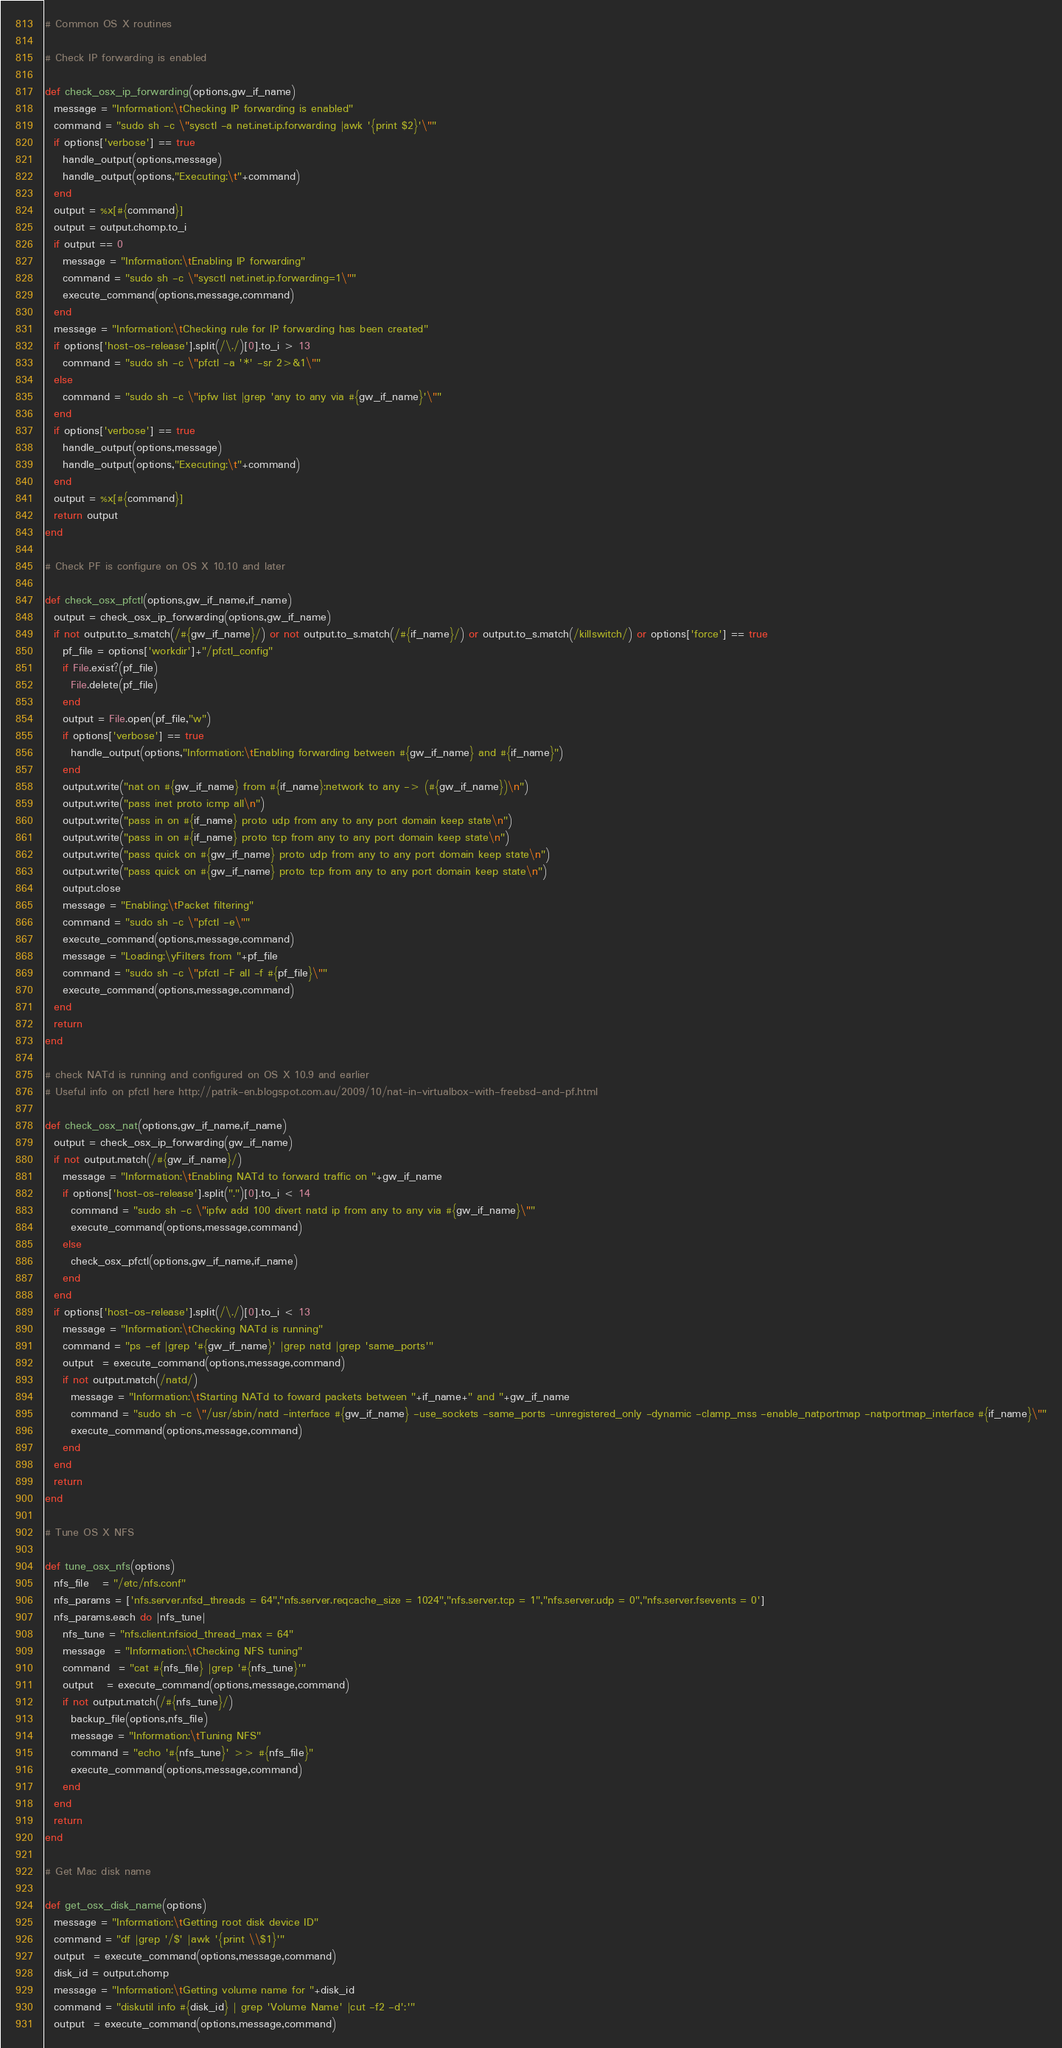<code> <loc_0><loc_0><loc_500><loc_500><_Ruby_># Common OS X routines

# Check IP forwarding is enabled

def check_osx_ip_forwarding(options,gw_if_name)
  message = "Information:\tChecking IP forwarding is enabled"
  command = "sudo sh -c \"sysctl -a net.inet.ip.forwarding |awk '{print $2}'\""
  if options['verbose'] == true
    handle_output(options,message)
    handle_output(options,"Executing:\t"+command)
  end
  output = %x[#{command}]
  output = output.chomp.to_i
  if output == 0
    message = "Information:\tEnabling IP forwarding"
    command = "sudo sh -c \"sysctl net.inet.ip.forwarding=1\""
    execute_command(options,message,command)
  end
  message = "Information:\tChecking rule for IP forwarding has been created"
  if options['host-os-release'].split(/\./)[0].to_i > 13
    command = "sudo sh -c \"pfctl -a '*' -sr 2>&1\""
  else
    command = "sudo sh -c \"ipfw list |grep 'any to any via #{gw_if_name}'\""
  end
  if options['verbose'] == true
    handle_output(options,message)
    handle_output(options,"Executing:\t"+command)
  end
  output = %x[#{command}]
  return output
end

# Check PF is configure on OS X 10.10 and later

def check_osx_pfctl(options,gw_if_name,if_name)
  output = check_osx_ip_forwarding(options,gw_if_name)
  if not output.to_s.match(/#{gw_if_name}/) or not output.to_s.match(/#{if_name}/) or output.to_s.match(/killswitch/) or options['force'] == true
    pf_file = options['workdir']+"/pfctl_config"
    if File.exist?(pf_file)
      File.delete(pf_file)
    end
    output = File.open(pf_file,"w")
    if options['verbose'] == true
      handle_output(options,"Information:\tEnabling forwarding between #{gw_if_name} and #{if_name}")
    end
    output.write("nat on #{gw_if_name} from #{if_name}:network to any -> (#{gw_if_name})\n")
    output.write("pass inet proto icmp all\n")
    output.write("pass in on #{if_name} proto udp from any to any port domain keep state\n")
    output.write("pass in on #{if_name} proto tcp from any to any port domain keep state\n")
    output.write("pass quick on #{gw_if_name} proto udp from any to any port domain keep state\n")
    output.write("pass quick on #{gw_if_name} proto tcp from any to any port domain keep state\n")
    output.close
    message = "Enabling:\tPacket filtering"
    command = "sudo sh -c \"pfctl -e\""
    execute_command(options,message,command)
    message = "Loading:\yFilters from "+pf_file
    command = "sudo sh -c \"pfctl -F all -f #{pf_file}\""
    execute_command(options,message,command)
  end
  return
end

# check NATd is running and configured on OS X 10.9 and earlier
# Useful info on pfctl here http://patrik-en.blogspot.com.au/2009/10/nat-in-virtualbox-with-freebsd-and-pf.html

def check_osx_nat(options,gw_if_name,if_name)
  output = check_osx_ip_forwarding(gw_if_name)
  if not output.match(/#{gw_if_name}/)
    message = "Information:\tEnabling NATd to forward traffic on "+gw_if_name
    if options['host-os-release'].split(".")[0].to_i < 14
      command = "sudo sh -c \"ipfw add 100 divert natd ip from any to any via #{gw_if_name}\""
      execute_command(options,message,command)
    else
      check_osx_pfctl(options,gw_if_name,if_name)
    end
  end
  if options['host-os-release'].split(/\./)[0].to_i < 13
    message = "Information:\tChecking NATd is running"
    command = "ps -ef |grep '#{gw_if_name}' |grep natd |grep 'same_ports'"
    output  = execute_command(options,message,command)
    if not output.match(/natd/)
      message = "Information:\tStarting NATd to foward packets between "+if_name+" and "+gw_if_name
      command = "sudo sh -c \"/usr/sbin/natd -interface #{gw_if_name} -use_sockets -same_ports -unregistered_only -dynamic -clamp_mss -enable_natportmap -natportmap_interface #{if_name}\""
      execute_command(options,message,command)
    end
  end
  return
end

# Tune OS X NFS

def tune_osx_nfs(options)
  nfs_file   = "/etc/nfs.conf"
  nfs_params = ['nfs.server.nfsd_threads = 64","nfs.server.reqcache_size = 1024","nfs.server.tcp = 1","nfs.server.udp = 0","nfs.server.fsevents = 0']
  nfs_params.each do |nfs_tune|
    nfs_tune = "nfs.client.nfsiod_thread_max = 64"
    message  = "Information:\tChecking NFS tuning"
    command  = "cat #{nfs_file} |grep '#{nfs_tune}'"
    output   = execute_command(options,message,command)
    if not output.match(/#{nfs_tune}/)
      backup_file(options,nfs_file)
      message = "Information:\tTuning NFS"
      command = "echo '#{nfs_tune}' >> #{nfs_file}"
      execute_command(options,message,command)
    end
  end
  return
end

# Get Mac disk name

def get_osx_disk_name(options)
  message = "Information:\tGetting root disk device ID"
  command = "df |grep '/$' |awk '{print \\$1}'"
  output  = execute_command(options,message,command)
  disk_id = output.chomp
  message = "Information:\tGetting volume name for "+disk_id
  command = "diskutil info #{disk_id} | grep 'Volume Name' |cut -f2 -d':'"
  output  = execute_command(options,message,command)</code> 